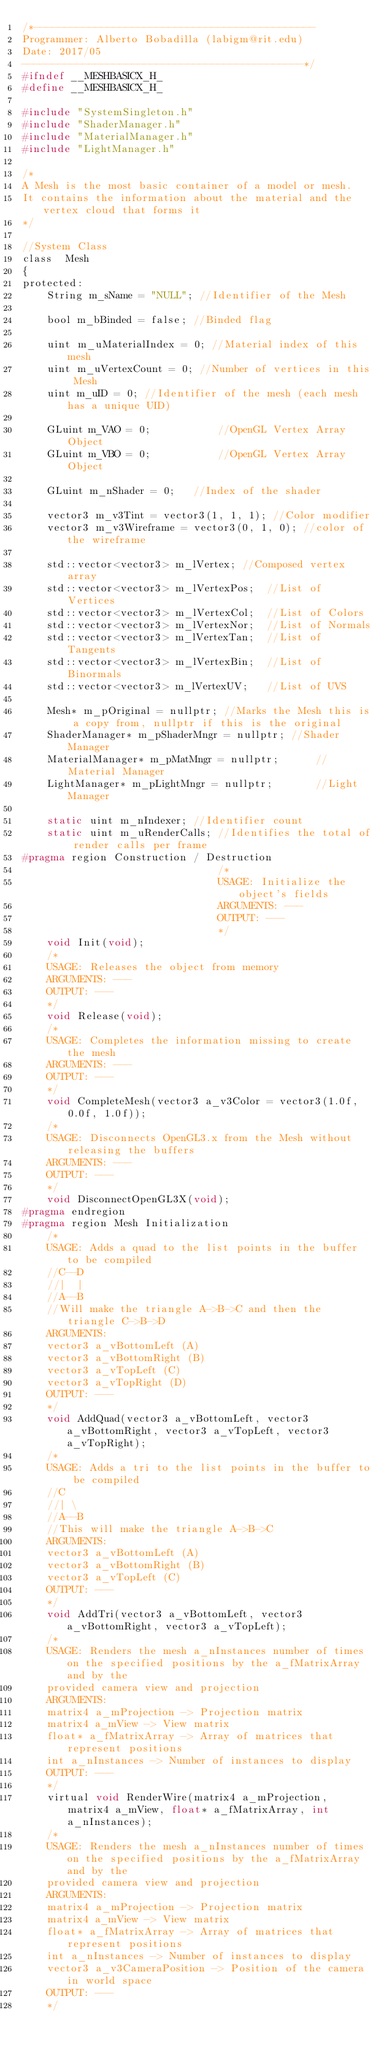Convert code to text. <code><loc_0><loc_0><loc_500><loc_500><_C_>/*----------------------------------------------
Programmer: Alberto Bobadilla (labigm@rit.edu)
Date: 2017/05
----------------------------------------------*/
#ifndef __MESHBASICX_H_
#define __MESHBASICX_H_

#include "SystemSingleton.h"
#include "ShaderManager.h"
#include "MaterialManager.h"
#include "LightManager.h"

/*
A Mesh is the most basic container of a model or mesh.
It contains the information about the material and the vertex cloud that forms it
*/

//System Class
class  Mesh
{
protected:
	String m_sName = "NULL"; //Identifier of the Mesh

	bool m_bBinded = false; //Binded flag

	uint m_uMaterialIndex = 0; //Material index of this mesh
	uint m_uVertexCount = 0; //Number of vertices in this Mesh
	uint m_uID = 0; //Identifier of the mesh (each mesh has a unique UID)

	GLuint m_VAO = 0;			//OpenGL Vertex Array Object
	GLuint m_VBO = 0;			//OpenGL Vertex Array Object

	GLuint m_nShader = 0;	//Index of the shader

	vector3 m_v3Tint = vector3(1, 1, 1); //Color modifier
	vector3 m_v3Wireframe = vector3(0, 1, 0); //color of the wireframe

	std::vector<vector3> m_lVertex; //Composed vertex array
	std::vector<vector3> m_lVertexPos;	//List of Vertices
	std::vector<vector3> m_lVertexCol;	//List of Colors
	std::vector<vector3> m_lVertexNor;	//List of Normals
	std::vector<vector3> m_lVertexTan;	//List of Tangents
	std::vector<vector3> m_lVertexBin;	//List of Binormals
	std::vector<vector3> m_lVertexUV;	//List of UVS

	Mesh* m_pOriginal = nullptr; //Marks the Mesh this is a copy from, nullptr if this is the original
	ShaderManager* m_pShaderMngr = nullptr;	//Shader Manager
	MaterialManager* m_pMatMngr = nullptr;		//Material Manager
	LightManager* m_pLightMngr = nullptr;		//Light Manager

	static uint m_nIndexer; //Identifier count
	static uint m_uRenderCalls; //Identifies the total of render calls per frame
#pragma region Construction / Destruction
								/*
								USAGE: Initialize the object's fields
								ARGUMENTS: ---
								OUTPUT: ---
								*/
	void Init(void);
	/*
	USAGE: Releases the object from memory
	ARGUMENTS: ---
	OUTPUT: ---
	*/
	void Release(void);
	/*
	USAGE: Completes the information missing to create the mesh
	ARGUMENTS: ---
	OUTPUT: ---
	*/
	void CompleteMesh(vector3 a_v3Color = vector3(1.0f, 0.0f, 1.0f));
	/*
	USAGE: Disconnects OpenGL3.x from the Mesh without releasing the buffers
	ARGUMENTS: ---
	OUTPUT: ---
	*/
	void DisconnectOpenGL3X(void);
#pragma endregion
#pragma region Mesh Initialization
	/*
	USAGE: Adds a quad to the list points in the buffer to be compiled
	//C--D
	//|  |
	//A--B
	//Will make the triangle A->B->C and then the triangle C->B->D
	ARGUMENTS:
	vector3 a_vBottomLeft (A)
	vector3 a_vBottomRight (B)
	vector3 a_vTopLeft (C)
	vector3 a_vTopRight (D)
	OUTPUT: ---
	*/
	void AddQuad(vector3 a_vBottomLeft, vector3 a_vBottomRight, vector3 a_vTopLeft, vector3 a_vTopRight);
	/*
	USAGE: Adds a tri to the list points in the buffer to be compiled
	//C
	//| \
	//A--B
	//This will make the triangle A->B->C
	ARGUMENTS:
	vector3 a_vBottomLeft (A)
	vector3 a_vBottomRight (B)
	vector3 a_vTopLeft (C)
	OUTPUT: ---
	*/
	void AddTri(vector3 a_vBottomLeft, vector3 a_vBottomRight, vector3 a_vTopLeft);
	/*
	USAGE: Renders the mesh a_nInstances number of times on the specified positions by the a_fMatrixArray and by the
	provided camera view and projection
	ARGUMENTS:
	matrix4 a_mProjection -> Projection matrix
	matrix4 a_mView -> View matrix
	float* a_fMatrixArray -> Array of matrices that represent positions
	int a_nInstances -> Number of instances to display
	OUTPUT: ---
	*/
	virtual void RenderWire(matrix4 a_mProjection, matrix4 a_mView, float* a_fMatrixArray, int a_nInstances);
	/*
	USAGE: Renders the mesh a_nInstances number of times on the specified positions by the a_fMatrixArray and by the
	provided camera view and projection
	ARGUMENTS:
	matrix4 a_mProjection -> Projection matrix
	matrix4 a_mView -> View matrix
	float* a_fMatrixArray -> Array of matrices that represent positions
	int a_nInstances -> Number of instances to display
	vector3 a_v3CameraPosition -> Position of the camera in world space
	OUTPUT: ---
	*/</code> 